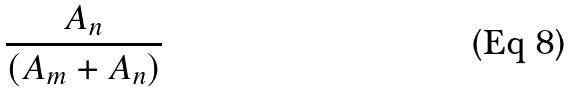<formula> <loc_0><loc_0><loc_500><loc_500>\frac { A _ { n } } { ( A _ { m } + A _ { n } ) }</formula> 